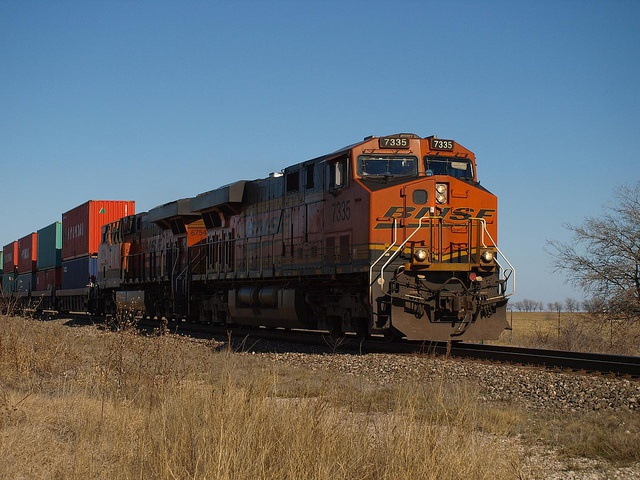Describe the objects in this image and their specific colors. I can see a train in gray, black, brown, and maroon tones in this image. 